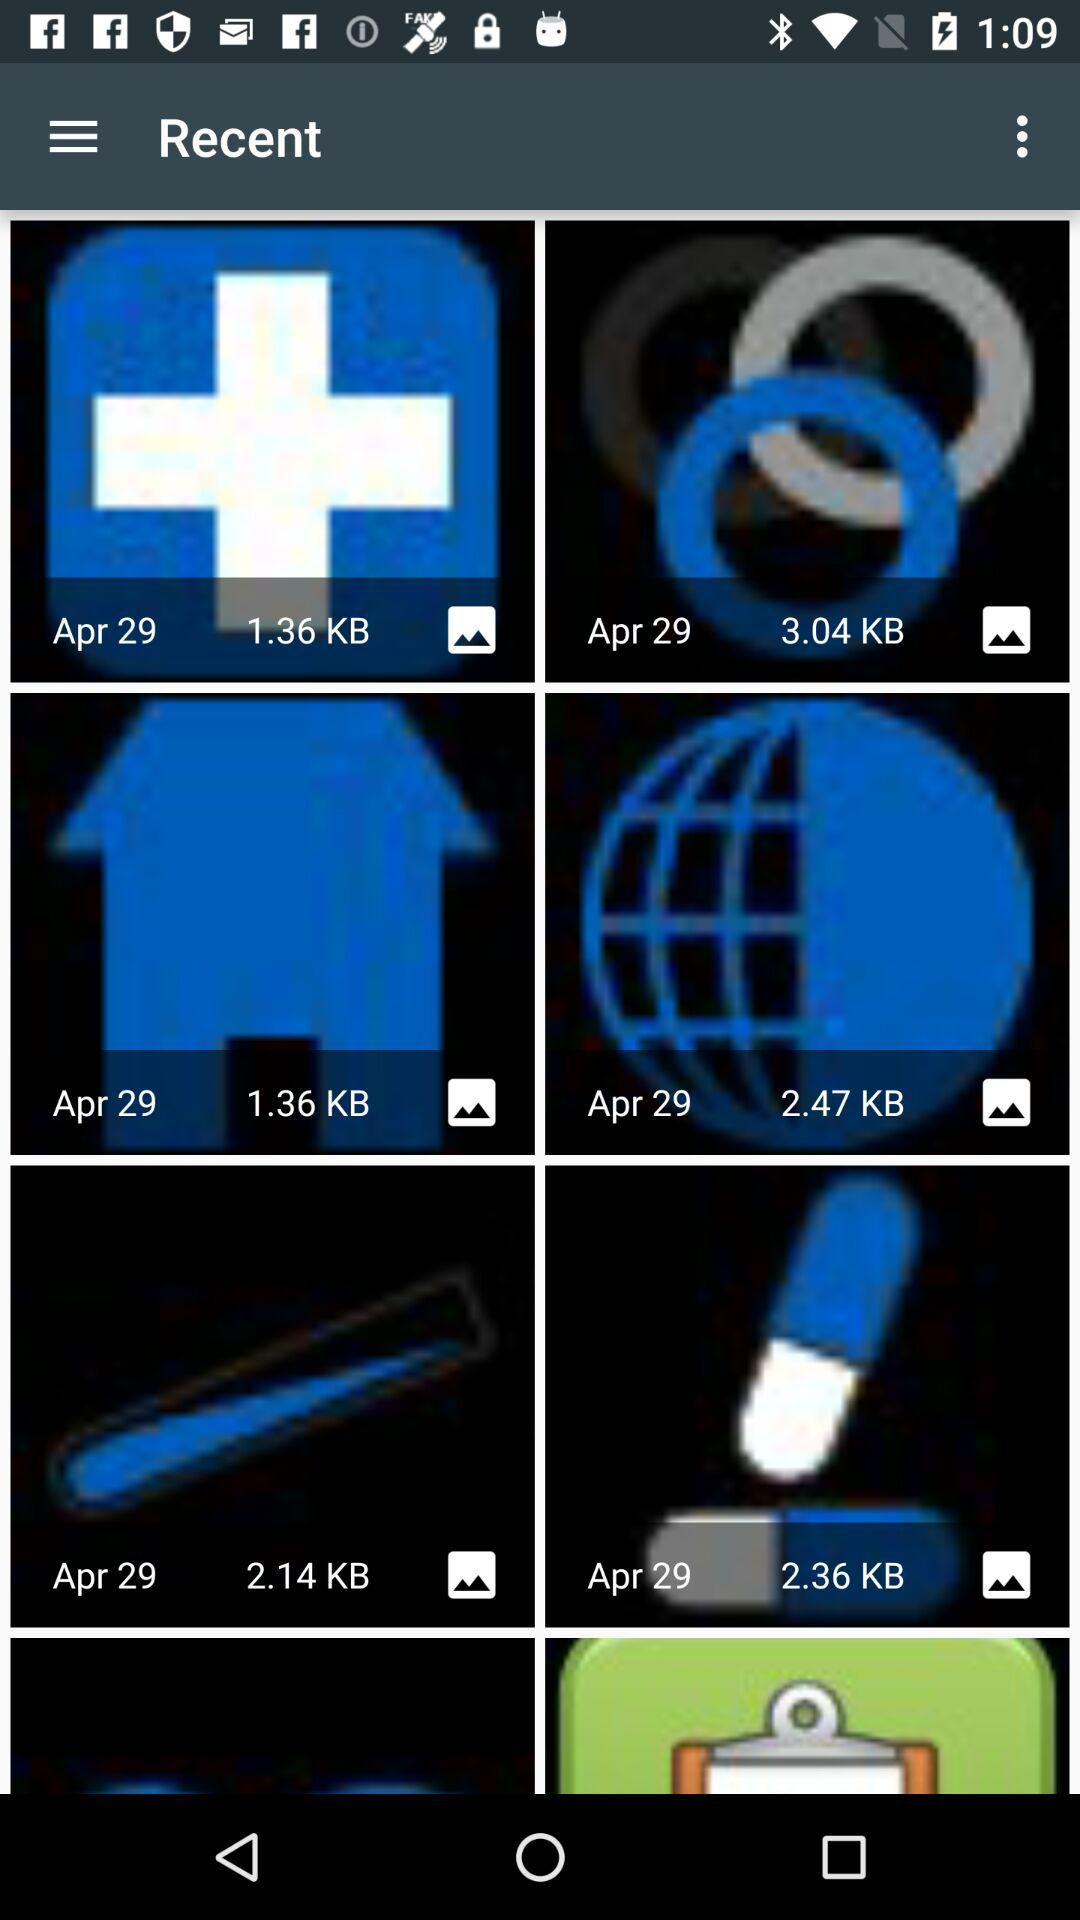What is the given unit of memory? The given unit is KB. 